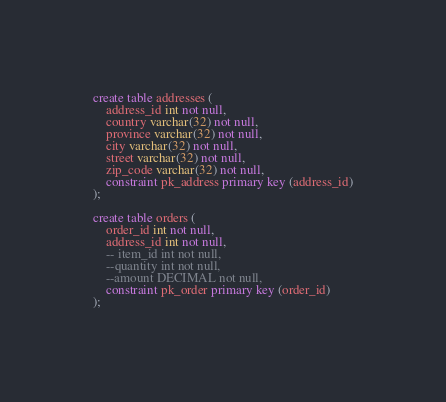<code> <loc_0><loc_0><loc_500><loc_500><_SQL_>create table addresses (
    address_id int not null,
    country varchar(32) not null,
    province varchar(32) not null,
    city varchar(32) not null,
    street varchar(32) not null,
    zip_code varchar(32) not null,
    constraint pk_address primary key (address_id)
);

create table orders (
    order_id int not null,
    address_id int not null,
    -- item_id int not null,
    --quantity int not null,
    --amount DECIMAL not null,
    constraint pk_order primary key (order_id)
);</code> 